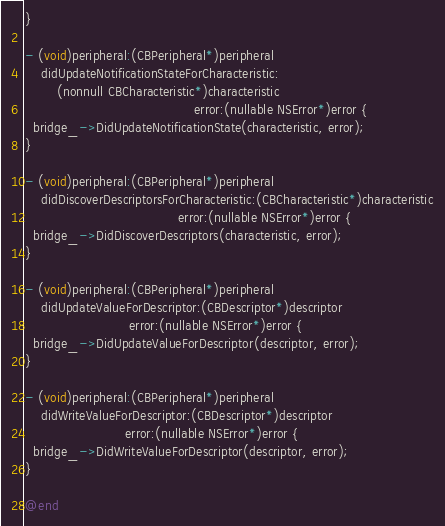<code> <loc_0><loc_0><loc_500><loc_500><_ObjectiveC_>}

- (void)peripheral:(CBPeripheral*)peripheral
    didUpdateNotificationStateForCharacteristic:
        (nonnull CBCharacteristic*)characteristic
                                          error:(nullable NSError*)error {
  bridge_->DidUpdateNotificationState(characteristic, error);
}

- (void)peripheral:(CBPeripheral*)peripheral
    didDiscoverDescriptorsForCharacteristic:(CBCharacteristic*)characteristic
                                      error:(nullable NSError*)error {
  bridge_->DidDiscoverDescriptors(characteristic, error);
}

- (void)peripheral:(CBPeripheral*)peripheral
    didUpdateValueForDescriptor:(CBDescriptor*)descriptor
                          error:(nullable NSError*)error {
  bridge_->DidUpdateValueForDescriptor(descriptor, error);
}

- (void)peripheral:(CBPeripheral*)peripheral
    didWriteValueForDescriptor:(CBDescriptor*)descriptor
                         error:(nullable NSError*)error {
  bridge_->DidWriteValueForDescriptor(descriptor, error);
}

@end
</code> 